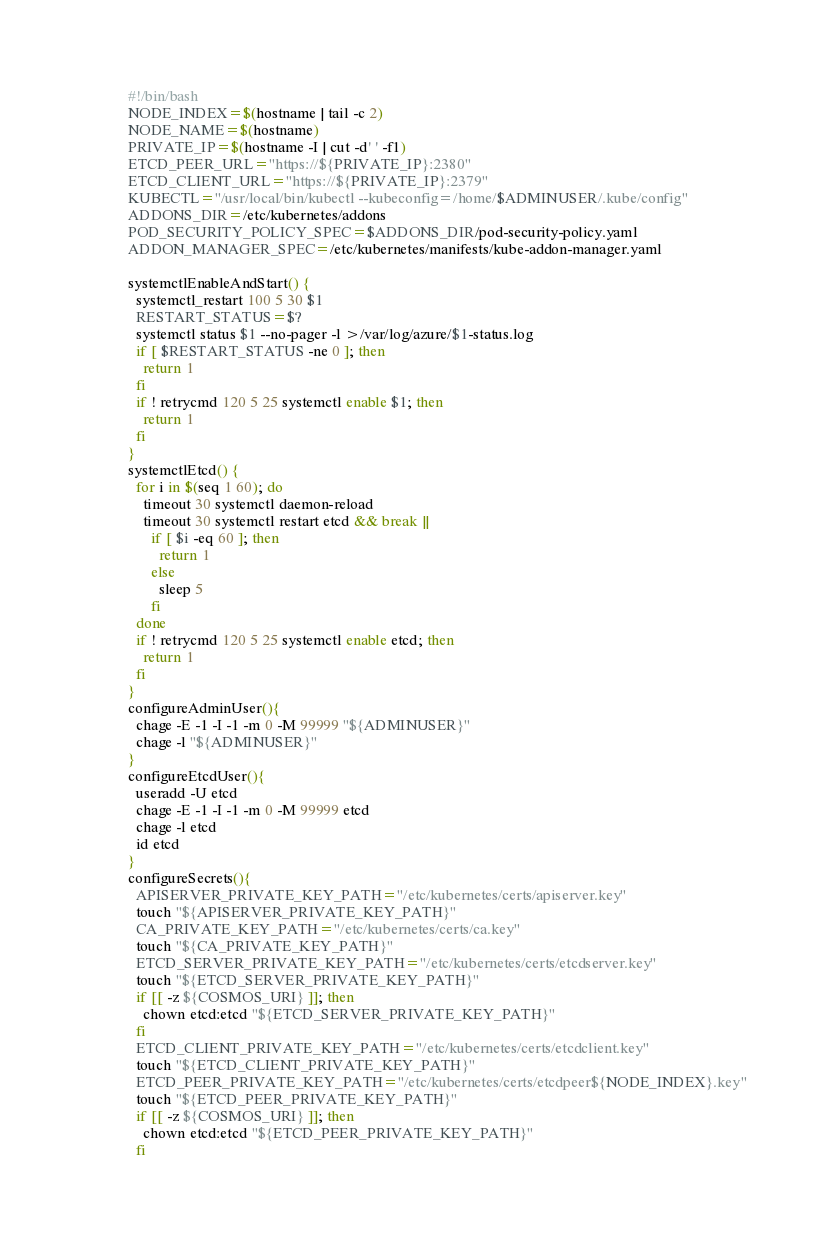<code> <loc_0><loc_0><loc_500><loc_500><_Bash_>#!/bin/bash
NODE_INDEX=$(hostname | tail -c 2)
NODE_NAME=$(hostname)
PRIVATE_IP=$(hostname -I | cut -d' ' -f1)
ETCD_PEER_URL="https://${PRIVATE_IP}:2380"
ETCD_CLIENT_URL="https://${PRIVATE_IP}:2379"
KUBECTL="/usr/local/bin/kubectl --kubeconfig=/home/$ADMINUSER/.kube/config"
ADDONS_DIR=/etc/kubernetes/addons
POD_SECURITY_POLICY_SPEC=$ADDONS_DIR/pod-security-policy.yaml
ADDON_MANAGER_SPEC=/etc/kubernetes/manifests/kube-addon-manager.yaml

systemctlEnableAndStart() {
  systemctl_restart 100 5 30 $1
  RESTART_STATUS=$?
  systemctl status $1 --no-pager -l >/var/log/azure/$1-status.log
  if [ $RESTART_STATUS -ne 0 ]; then
    return 1
  fi
  if ! retrycmd 120 5 25 systemctl enable $1; then
    return 1
  fi
}
systemctlEtcd() {
  for i in $(seq 1 60); do
    timeout 30 systemctl daemon-reload
    timeout 30 systemctl restart etcd && break ||
      if [ $i -eq 60 ]; then
        return 1
      else
        sleep 5
      fi
  done
  if ! retrycmd 120 5 25 systemctl enable etcd; then
    return 1
  fi
}
configureAdminUser(){
  chage -E -1 -I -1 -m 0 -M 99999 "${ADMINUSER}"
  chage -l "${ADMINUSER}"
}
configureEtcdUser(){
  useradd -U etcd
  chage -E -1 -I -1 -m 0 -M 99999 etcd
  chage -l etcd
  id etcd
}
configureSecrets(){
  APISERVER_PRIVATE_KEY_PATH="/etc/kubernetes/certs/apiserver.key"
  touch "${APISERVER_PRIVATE_KEY_PATH}"
  CA_PRIVATE_KEY_PATH="/etc/kubernetes/certs/ca.key"
  touch "${CA_PRIVATE_KEY_PATH}"
  ETCD_SERVER_PRIVATE_KEY_PATH="/etc/kubernetes/certs/etcdserver.key"
  touch "${ETCD_SERVER_PRIVATE_KEY_PATH}"
  if [[ -z ${COSMOS_URI} ]]; then
    chown etcd:etcd "${ETCD_SERVER_PRIVATE_KEY_PATH}"
  fi
  ETCD_CLIENT_PRIVATE_KEY_PATH="/etc/kubernetes/certs/etcdclient.key"
  touch "${ETCD_CLIENT_PRIVATE_KEY_PATH}"
  ETCD_PEER_PRIVATE_KEY_PATH="/etc/kubernetes/certs/etcdpeer${NODE_INDEX}.key"
  touch "${ETCD_PEER_PRIVATE_KEY_PATH}"
  if [[ -z ${COSMOS_URI} ]]; then
    chown etcd:etcd "${ETCD_PEER_PRIVATE_KEY_PATH}"
  fi</code> 